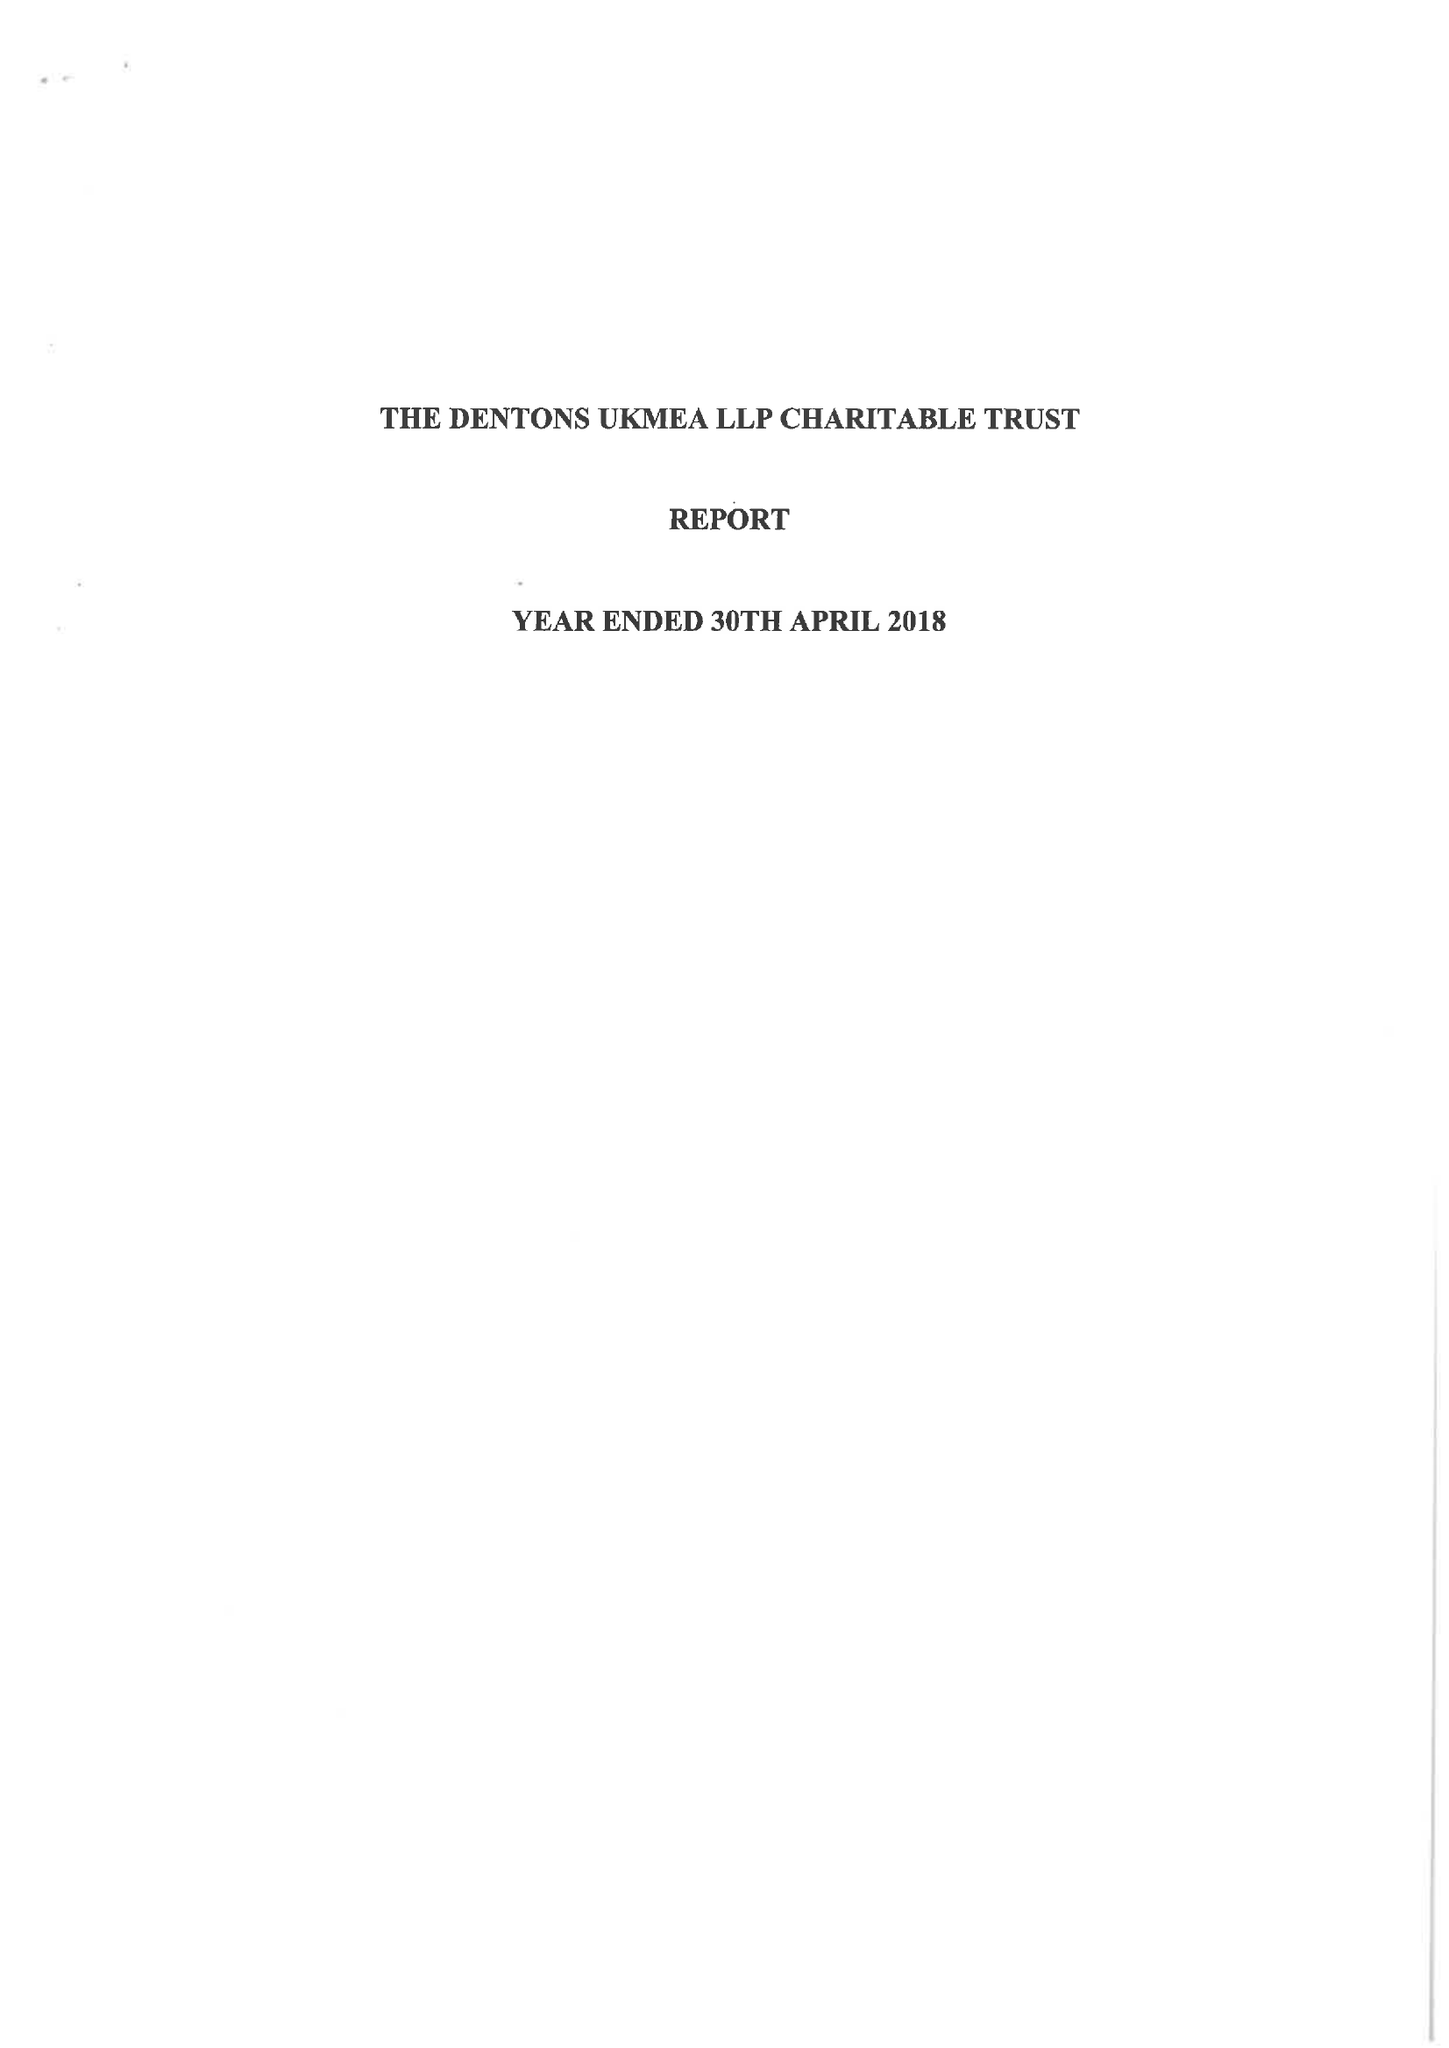What is the value for the charity_name?
Answer the question using a single word or phrase. Dentons Ukmea LLP 